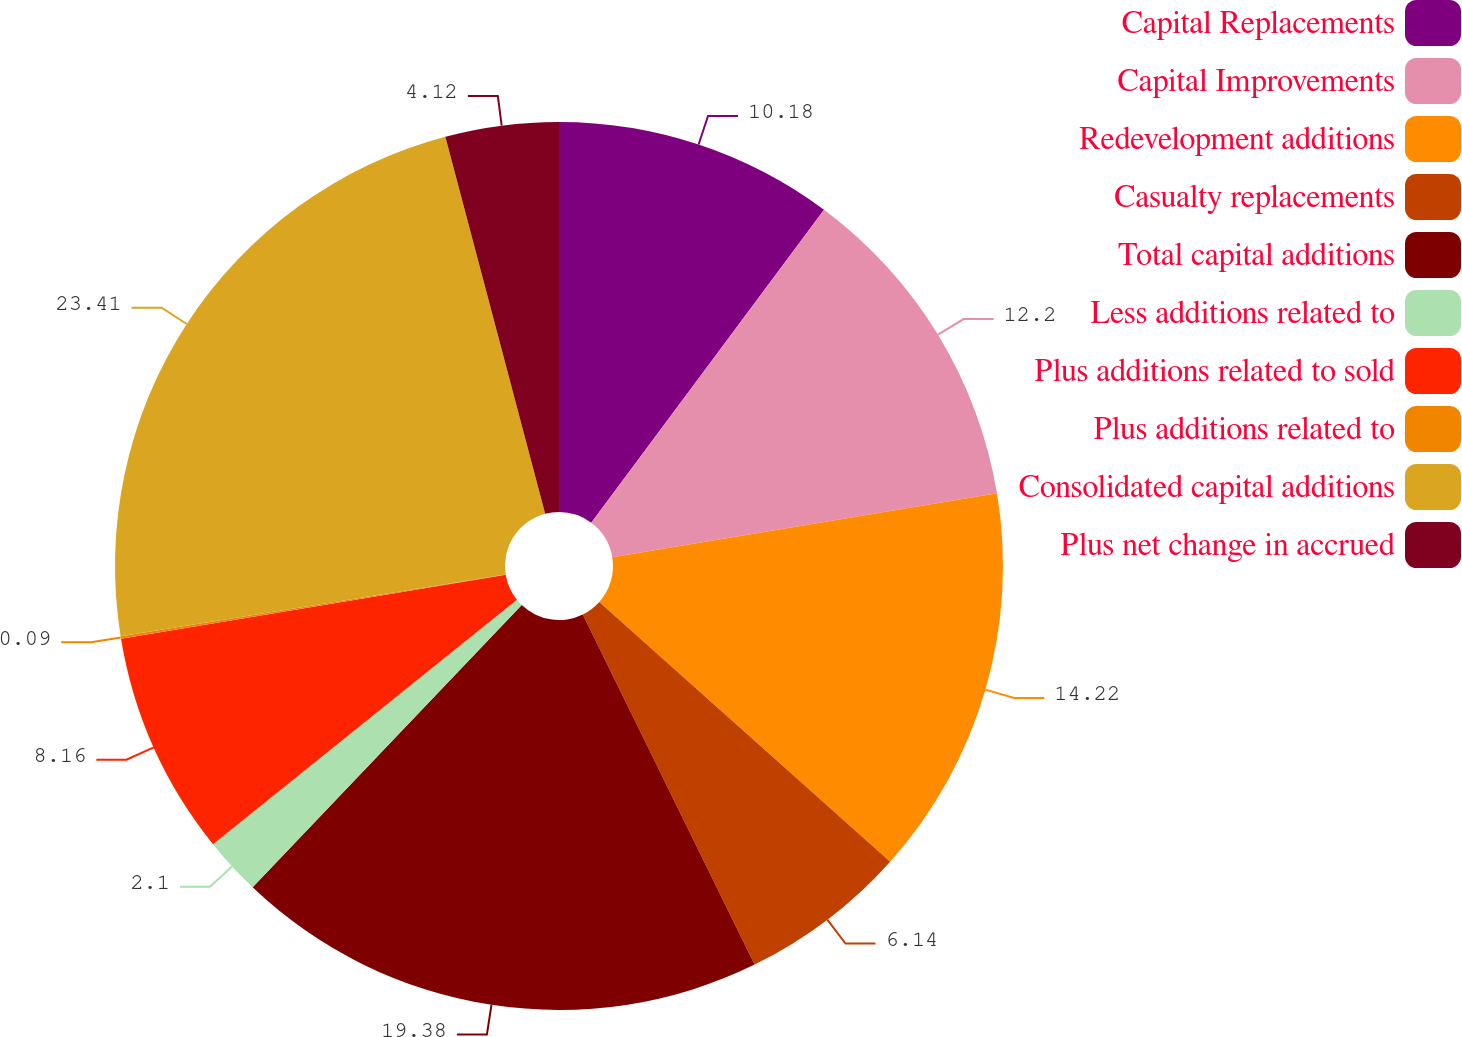Convert chart to OTSL. <chart><loc_0><loc_0><loc_500><loc_500><pie_chart><fcel>Capital Replacements<fcel>Capital Improvements<fcel>Redevelopment additions<fcel>Casualty replacements<fcel>Total capital additions<fcel>Less additions related to<fcel>Plus additions related to sold<fcel>Plus additions related to<fcel>Consolidated capital additions<fcel>Plus net change in accrued<nl><fcel>10.18%<fcel>12.2%<fcel>14.22%<fcel>6.14%<fcel>19.38%<fcel>2.1%<fcel>8.16%<fcel>0.09%<fcel>23.41%<fcel>4.12%<nl></chart> 